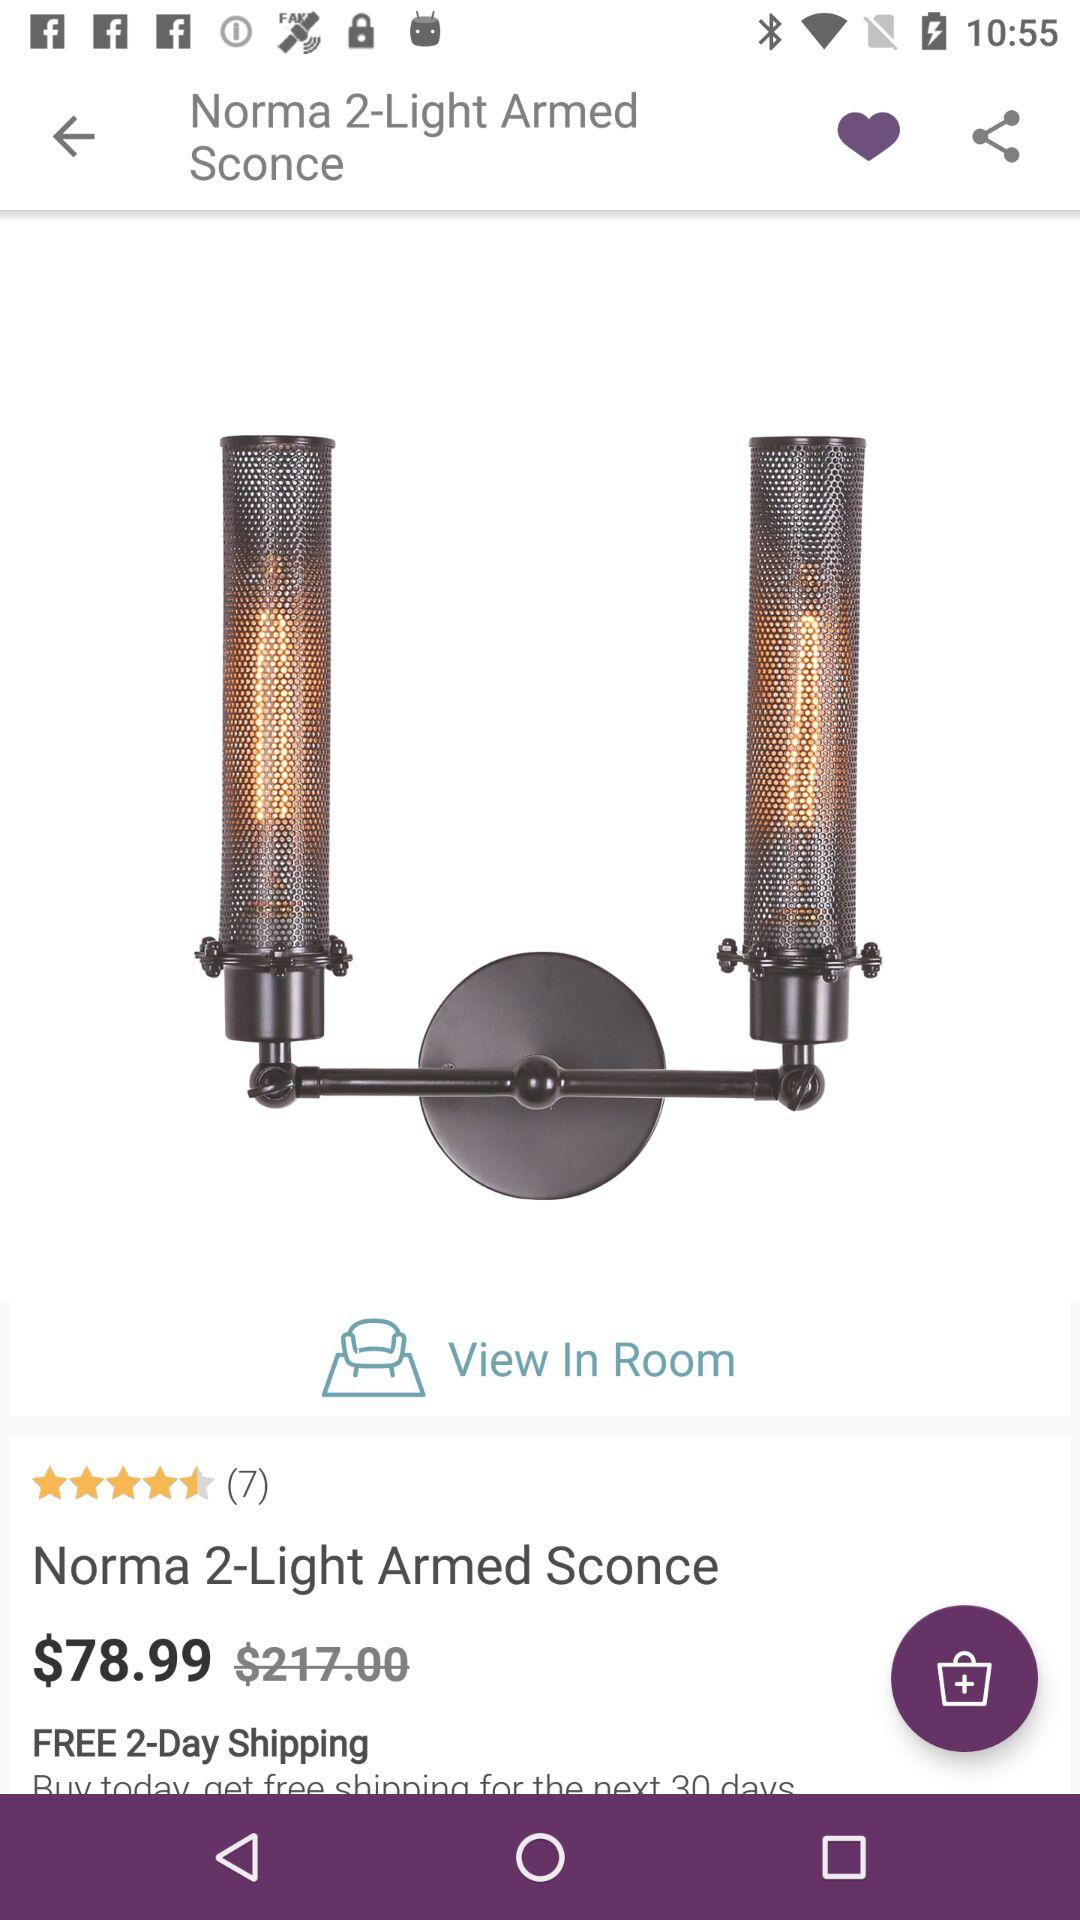How many free shipping days are there for this product? There are two free shipping days. 